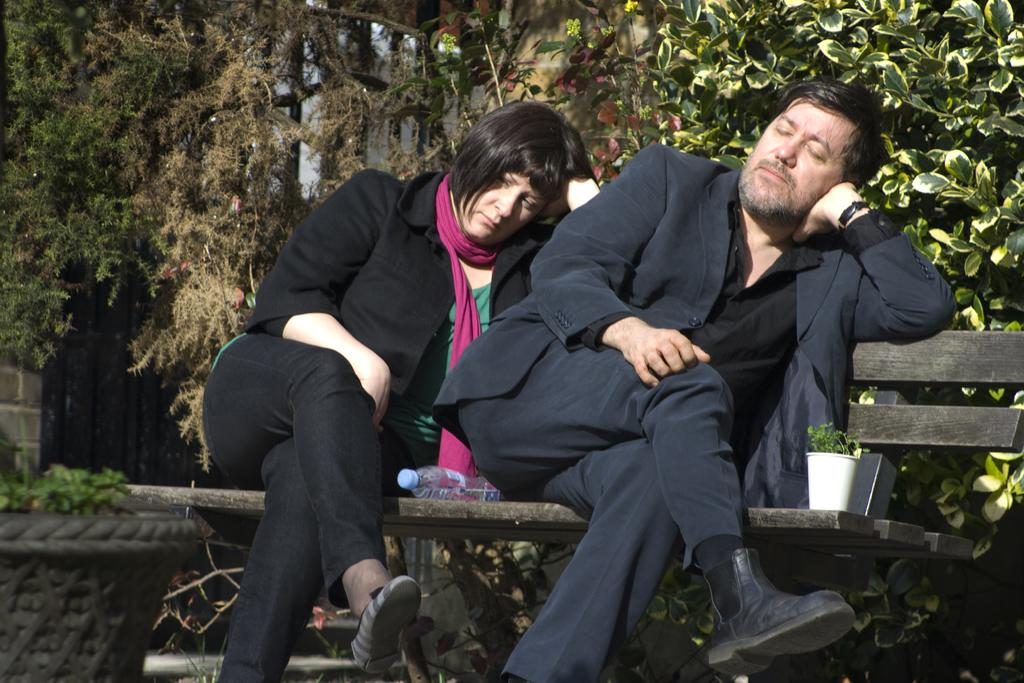How many people are present in the image? There are two people in the image. What are the two people doing in the image? The two people are sitting on a wooden table. What can be seen in the background of the image? There is a tree in the background of the image. How many eggs are visible in the image? There are no eggs present in the image. What type of breath can be seen coming from the tree in the background? There is no breath visible in the image, as trees do not have the ability to breathe. 